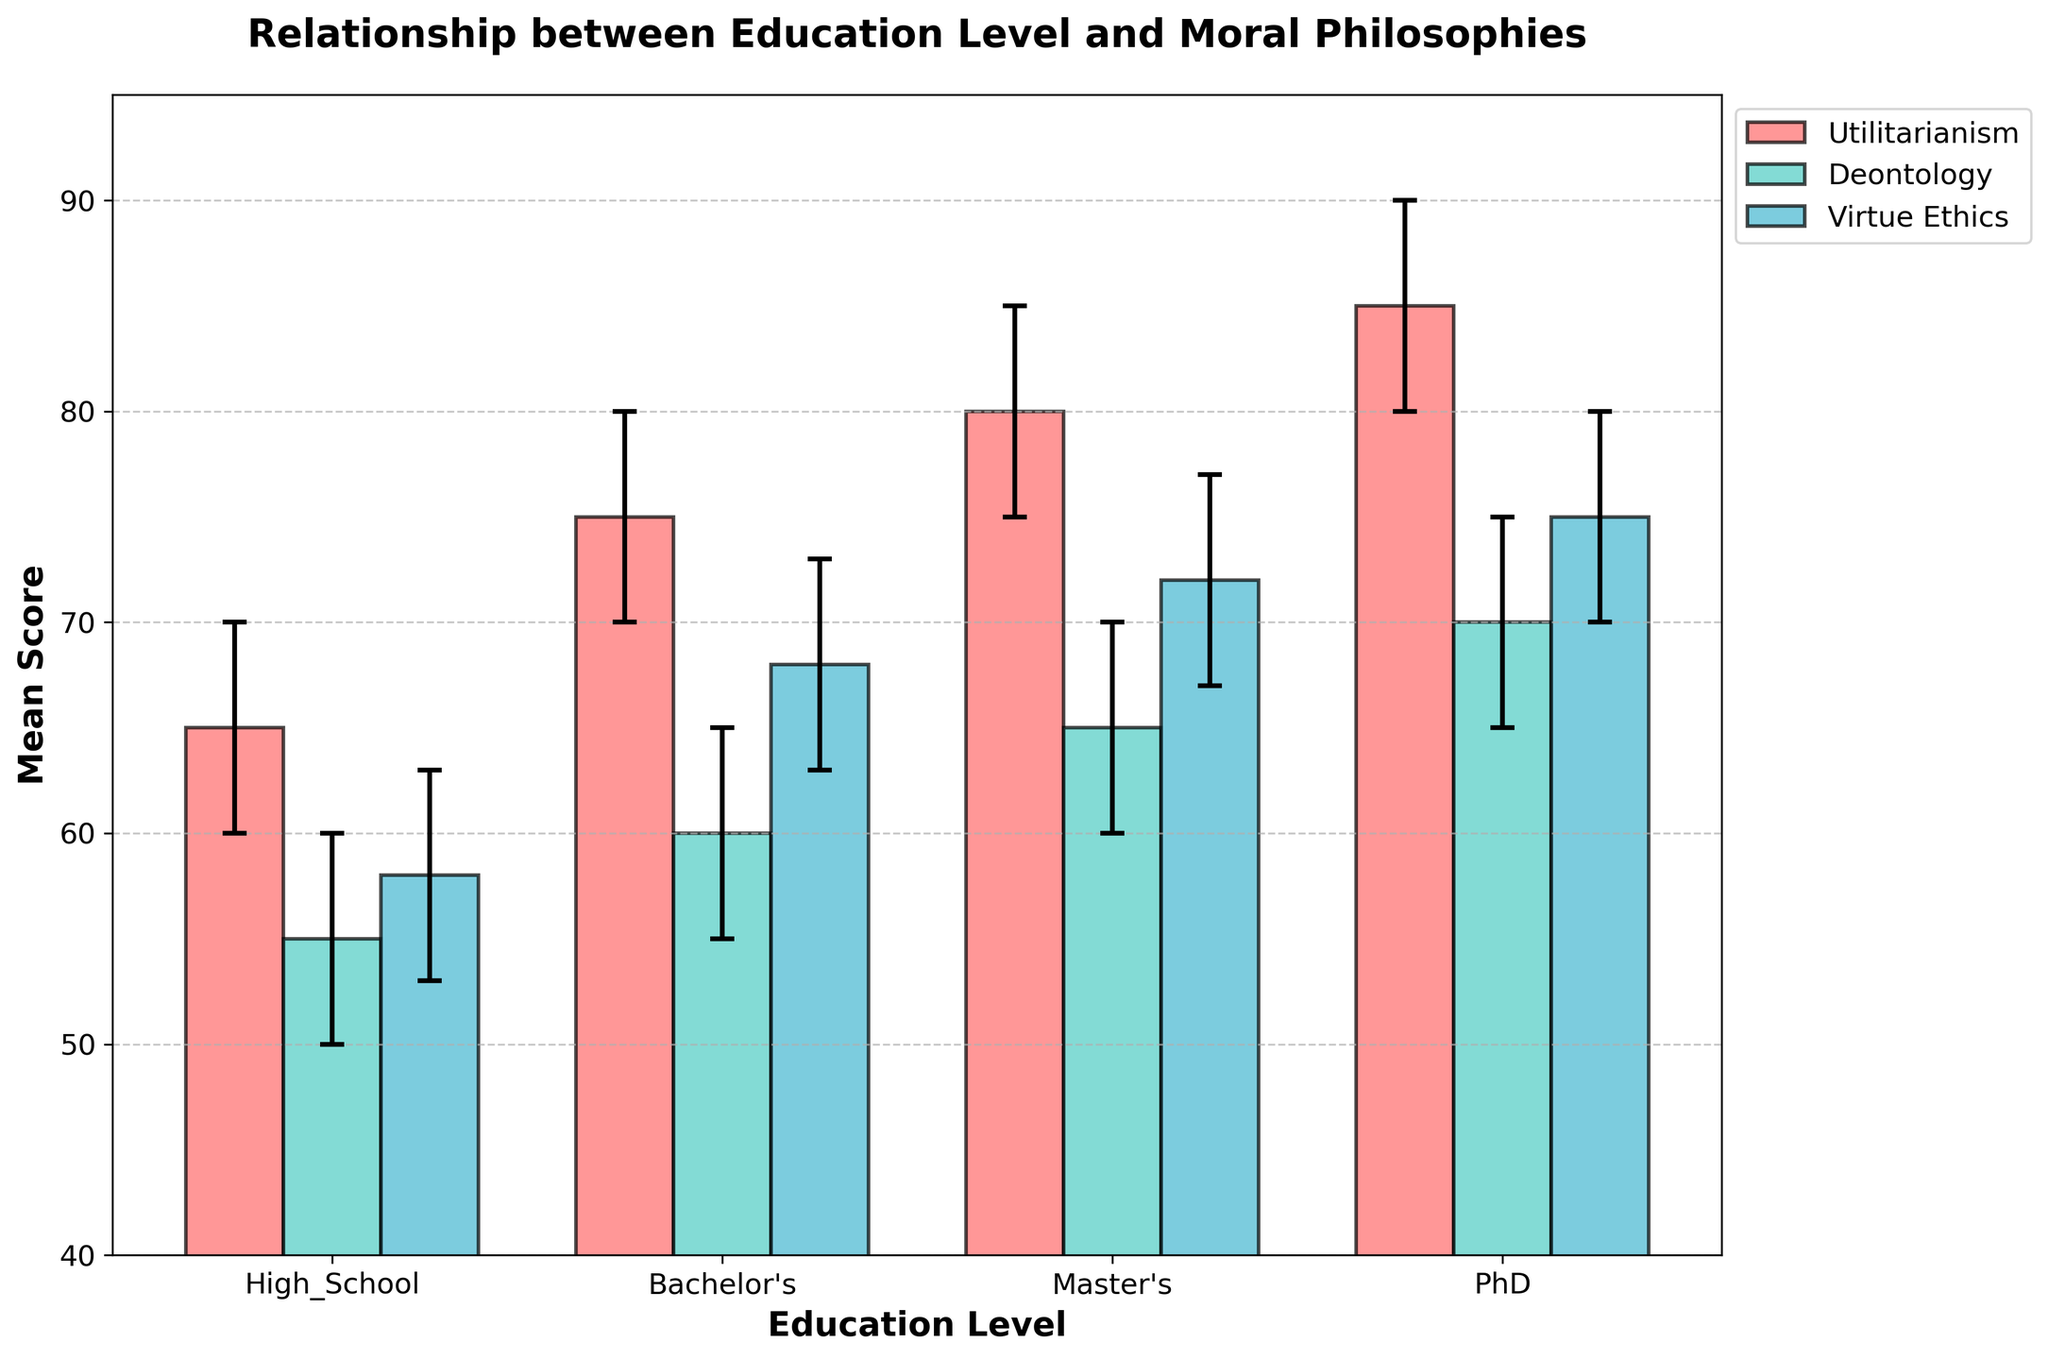Who scored the highest in Utilitarianism? The highest scores in Utilitarianism can be seen at the education level of PhD, where the mean score is 85 within a confidence interval of 80 to 90.
Answer: PhD How does the mean score of Deontology change with increasing education levels? Starting from high school and proceeding to PhD, the mean scores for Deontology increase as follows: High School (55), Bachelor's (60), Master's (65), and PhD (70).
Answer: It increases Which moral philosophy has the lowest mean score at the Bachelor's level? At the Bachelor's education level, the mean scores for the moral philosophies are: Utilitarianism (75), Deontology (60), and Virtue Ethics (68). The lowest mean score is in Deontology.
Answer: Deontology Compare the confidence intervals of Virtue Ethics for Master's and PhD levels. Which level has a wider interval? For Master's level, the confidence interval of Virtue Ethics is [67, 77], and for PhD level, it is [70, 80]. Both intervals have a range of 10 points.
Answer: They are the same What is the difference in mean scores of Deontology between High School and PhD levels? The mean score for Deontology at High School is 55 and at PhD is 70. The difference is calculated as 70 - 55 = 15.
Answer: 15 Which philosophy shows the least variance in confidence intervals across different education levels? By examining the confidence intervals for each moral philosophy across education levels, Deontology has intervals of equal width (10 points) consistently, while Utilitarianism and Virtue Ethics show slightly more variance.
Answer: Deontology Are any confidence intervals overlapping for Virtue Ethics across all education levels? The confidence intervals for Virtue Ethics across education levels are: High School [53, 63], Bachelor's [63, 73], Master's [67, 77], and PhD [70, 80]. There are overlaps between Bachelor's and Master's, and Master's and PhD intervals.
Answer: Yes 